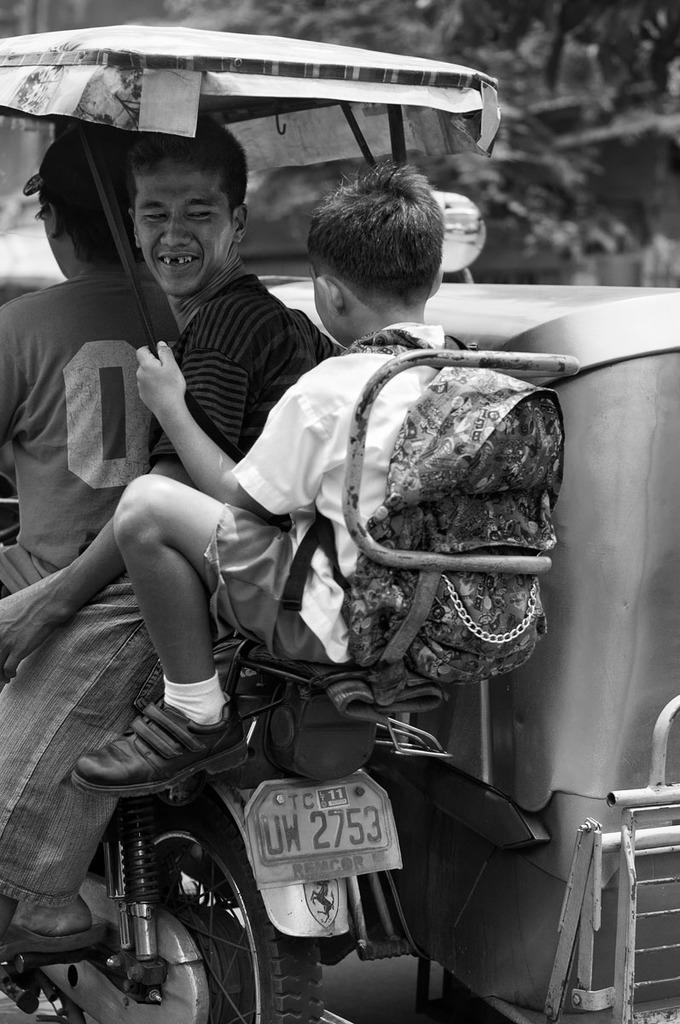How many people are on the vehicle in the image? There are three persons sitting on the vehicle in the image. What is one person doing while on the vehicle? One person is riding the vehicle. What is one person holding while on the vehicle? One person is holding an umbrella. What is one person wearing while on the vehicle? One person is wearing a bag. What can be seen in the background of the image? There are trees in the background. What direction is the donkey facing in the image? There is no donkey present in the image. What type of tooth can be seen in the image? There are no teeth visible in the image. 